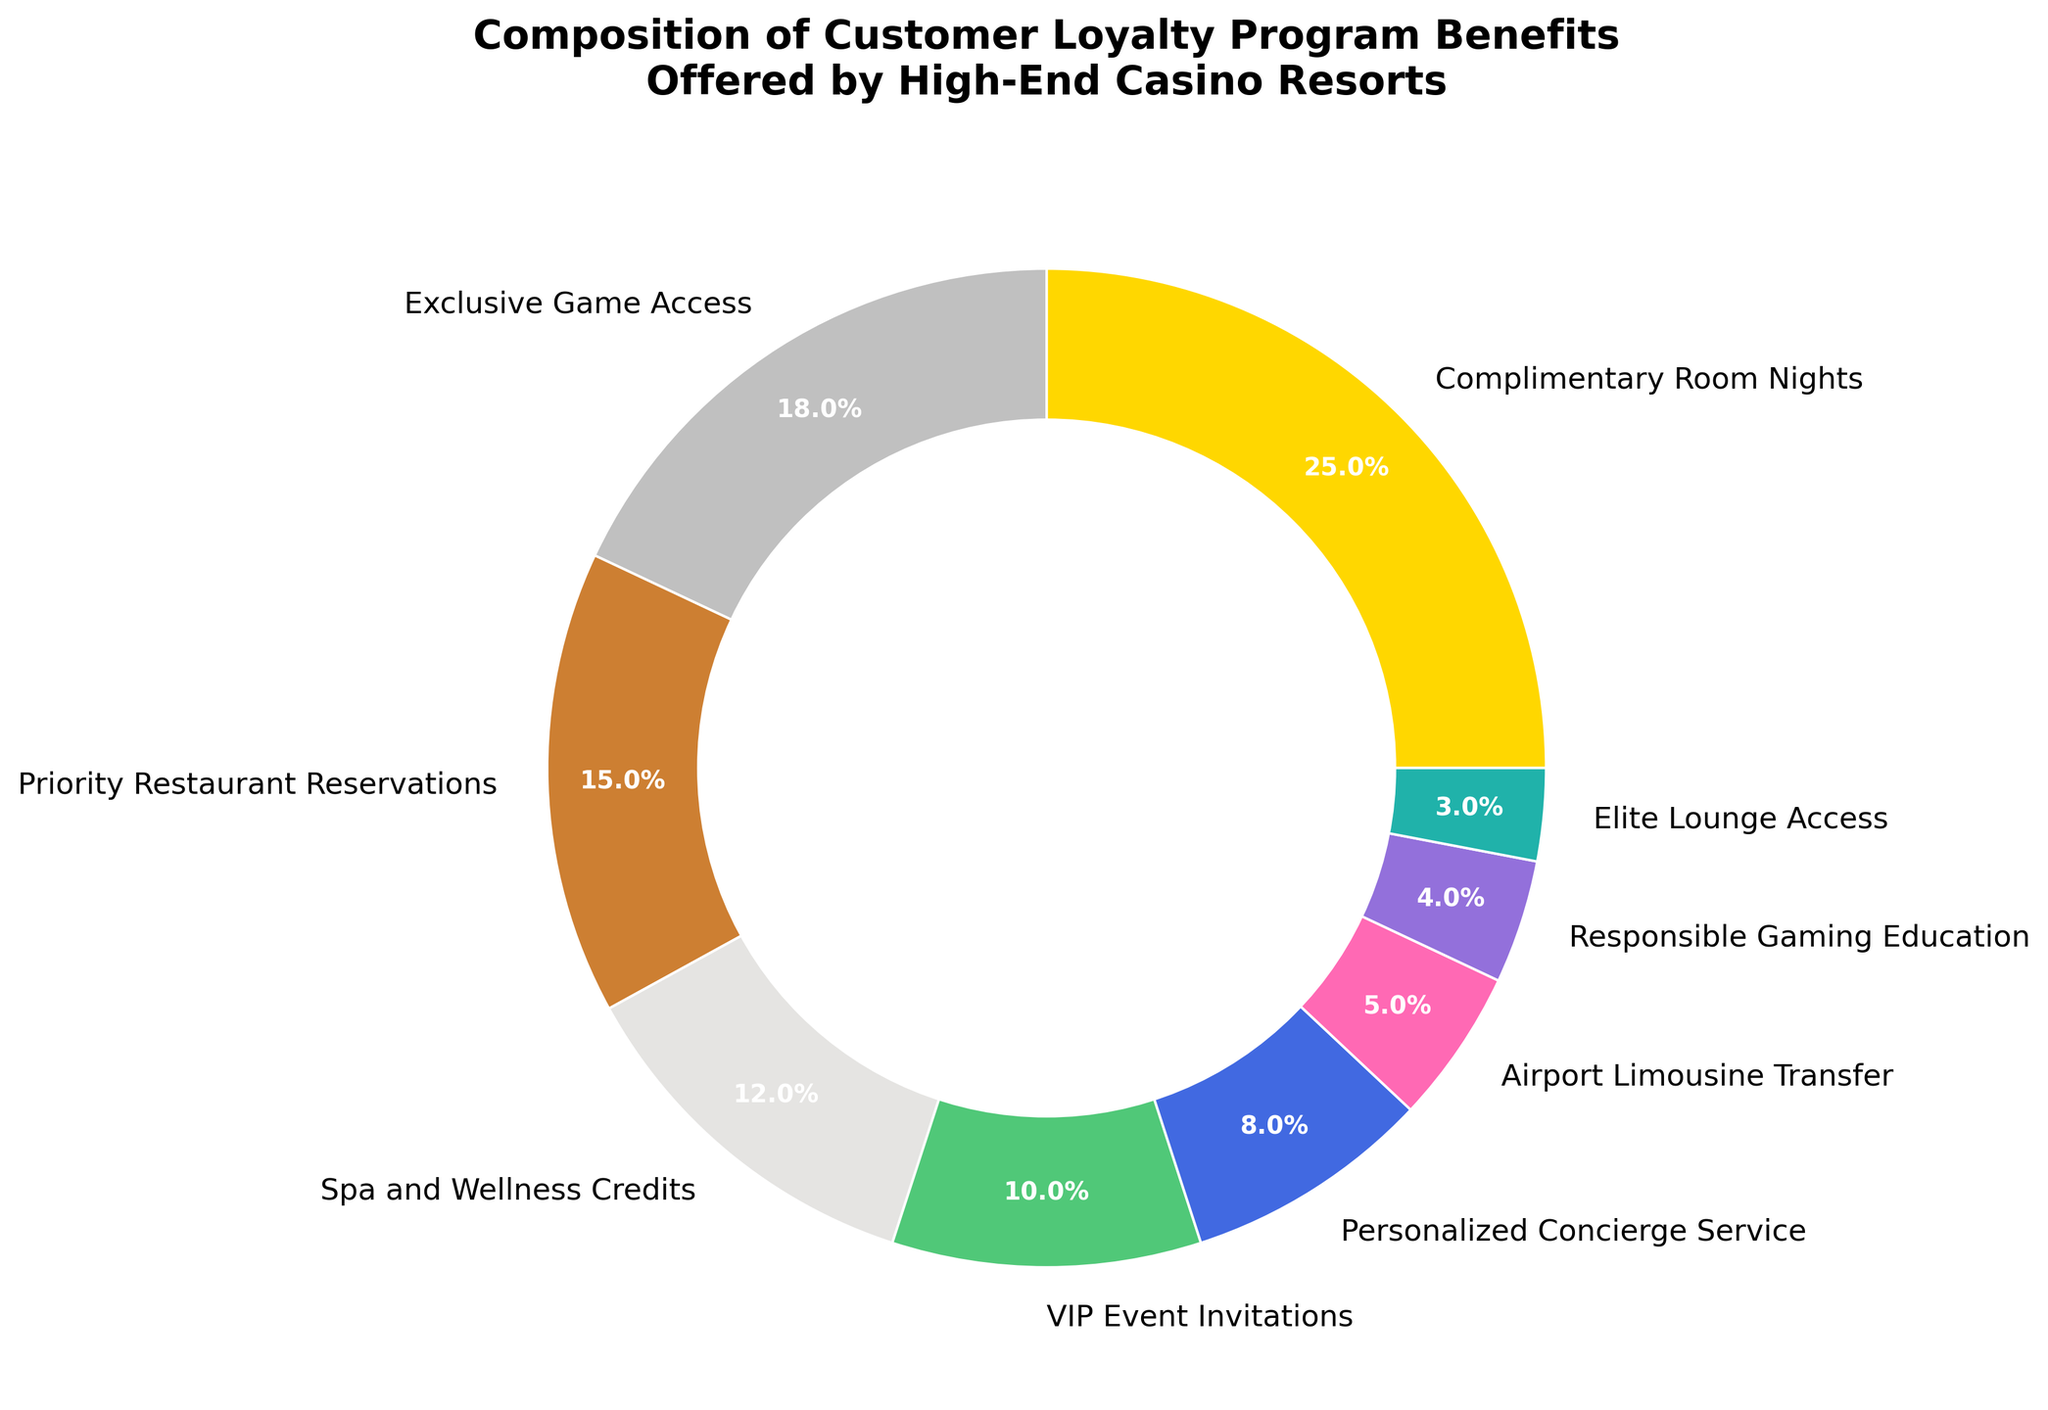Which benefit is most frequently offered in the customer loyalty program? The largest slice in the pie chart represents the most frequently offered benefit. It is labeled as "Complimentary Room Nights" with 25%.
Answer: Complimentary Room Nights Which benefit occupies the smallest portion of the pie? The smallest slice in the pie chart represents the least frequently offered benefit. It is labeled as "Elite Lounge Access" with 3%.
Answer: Elite Lounge Access What is the combined percentage of benefits related to dining and wellness? The benefits related to dining and wellness are "Priority Restaurant Reservations" (15%) and "Spa and Wellness Credits" (12%). Adding them together gives 15% + 12% = 27%.
Answer: 27% How much more popular is "Complimentary Room Nights" compared to "Exclusive Game Access"? "Complimentary Room Nights" has 25% while "Exclusive Game Access" has 18%. The difference is calculated as 25% - 18% = 7%.
Answer: 7% Which two benefits together account for the same percentage as "Complimentary Room Nights"? "Priority Restaurant Reservations" is 15% and "Spa and Wellness Credits" is 12%. Adding them together, 15% + 12% = 27%, which is close to the 25% of "Complimentary Room Nights." However, this is not exact. Instead, "Priority Restaurant Reservations" (15%) and "VIP Event Invitations" (10%), combined equal 25%.
Answer: Priority Restaurant Reservations and VIP Event Invitations What percentage of the benefits offered are related to exclusive experiences (including "Exclusive Game Access" and "VIP Event Invitations")? Adding the "Exclusive Game Access" (18%) and "VIP Event Invitations" (10%) gives 18% + 10% = 28%.
Answer: 28% How do the benefits related to wellness compare with those related to personalized services? "Spa and Wellness Credits" (12%) compared to "Personalized Concierge Service" (8%). 12% > 8%, so wellness benefits are more widely offered.
Answer: Wellness benefits are more widely offered What is the percentage difference between "VIP Event Invitations" and "Airport Limousine Transfer"? The percentages are 10% for "VIP Event Invitations" and 5% for "Airport Limousine Transfer". The difference is 10% - 5% = 5%.
Answer: 5% If you combine the percentages of the two least offered benefits, what do you get? The two least offered benefits are "Elite Lounge Access" (3%) and "Responsible Gaming Education" (4%). The sum is 3% + 4% = 7%.
Answer: 7% 